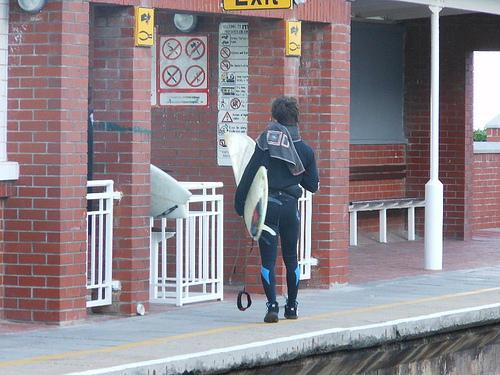Explain the visual features of the environment surrounding the main subject. The environment includes a stone transit platform, brickwork doorways, white supporting pillar, white seating bench, white transit gate, and white fencing against a red brick wall. For the multi-choice VQA task, mention an example question and its answer based on the image and captions given. Answer: c) White. Identify the main subject in the image and mention the predominant colors they are wearing. Man carrying surfboard wearing a black and blue wetsuit. List down the elements in the image that make it a suitable scene for a product advertisement task. Surfer with surfboard, surfer in wetsuit, white surfboard, young person carrying short surfboard, surfboard leash, and young man in full wet suit. 